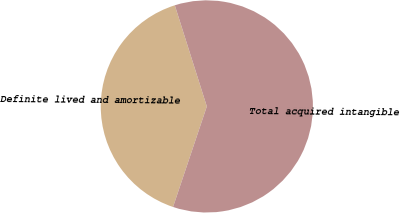<chart> <loc_0><loc_0><loc_500><loc_500><pie_chart><fcel>Definite lived and amortizable<fcel>Total acquired intangible<nl><fcel>39.96%<fcel>60.04%<nl></chart> 